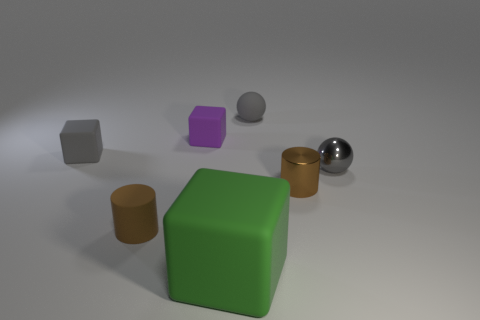Subtract all small rubber cubes. How many cubes are left? 1 Add 3 tiny gray metallic spheres. How many objects exist? 10 Subtract all cubes. How many objects are left? 4 Subtract all cyan blocks. Subtract all gray cylinders. How many blocks are left? 3 Subtract all small cubes. Subtract all matte cylinders. How many objects are left? 4 Add 7 gray spheres. How many gray spheres are left? 9 Add 6 small brown matte objects. How many small brown matte objects exist? 7 Subtract 1 gray cubes. How many objects are left? 6 